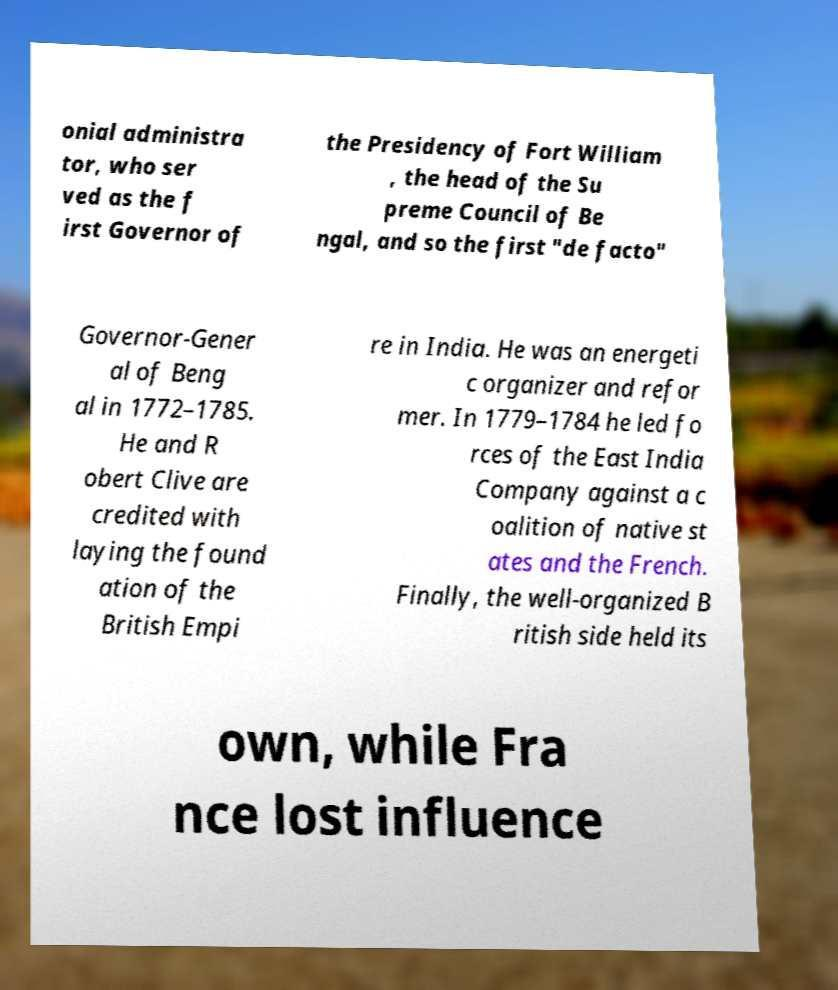What messages or text are displayed in this image? I need them in a readable, typed format. onial administra tor, who ser ved as the f irst Governor of the Presidency of Fort William , the head of the Su preme Council of Be ngal, and so the first "de facto" Governor-Gener al of Beng al in 1772–1785. He and R obert Clive are credited with laying the found ation of the British Empi re in India. He was an energeti c organizer and refor mer. In 1779–1784 he led fo rces of the East India Company against a c oalition of native st ates and the French. Finally, the well-organized B ritish side held its own, while Fra nce lost influence 